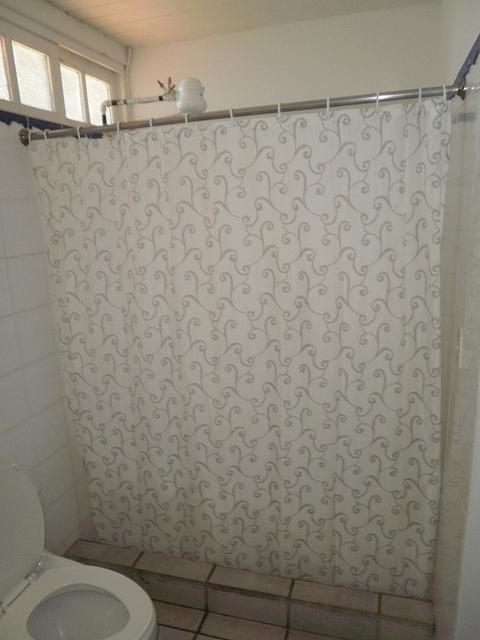How many of the people are on a horse?
Give a very brief answer. 0. 